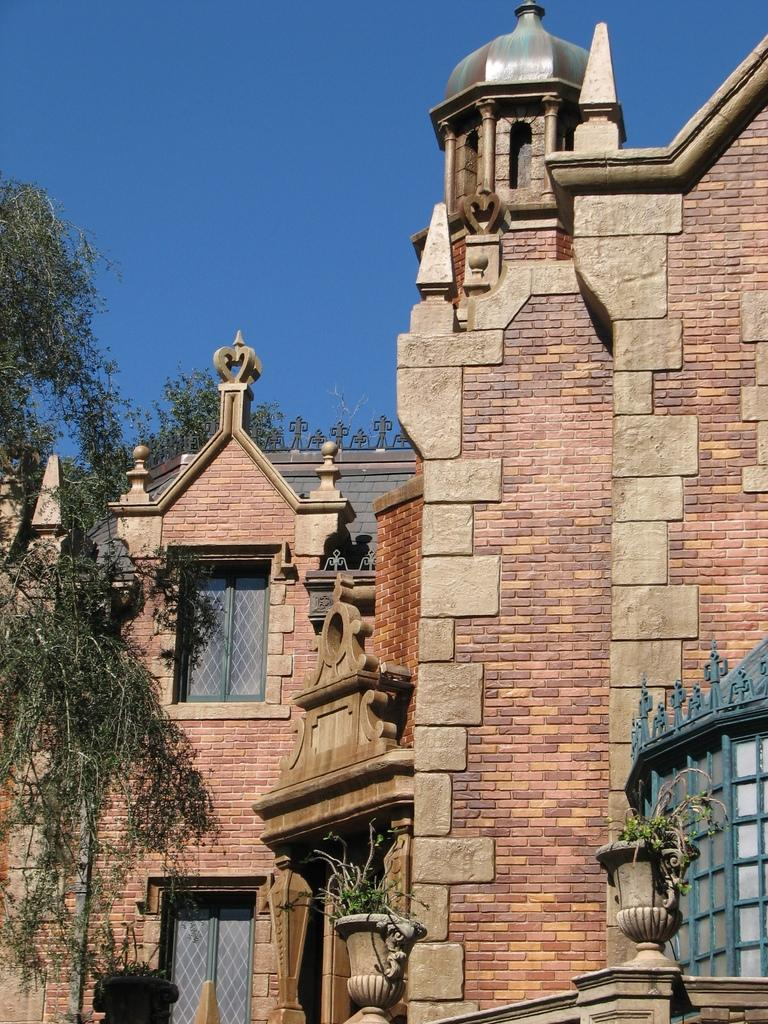What type of vegetation can be seen in the image? There are trees in the image. What type of structures are present in the image? There are buildings with windows in the image. What is visible in the background of the image? The sky is visible in the background of the image. What type of smoke can be seen coming from the buildings in the image? There is no smoke visible in the image; only trees, buildings, and the sky are present. What type of beef is being served at the restaurant in the image? There is no restaurant or beef present in the image. 